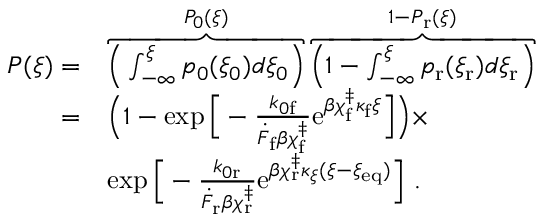Convert formula to latex. <formula><loc_0><loc_0><loc_500><loc_500>\begin{array} { r l } { P ( \xi ) = } & { \overbrace { \left ( \int _ { - \infty } ^ { \xi } p _ { 0 } ( \xi _ { 0 } ) d \xi _ { 0 } \right ) } ^ { P _ { 0 } ( \xi ) } \overbrace { \left ( 1 - \int _ { - \infty } ^ { \xi } p _ { r } ( \xi _ { r } ) d \xi _ { r } \right ) } ^ { 1 - P _ { r } ( \xi ) } } \\ { = } & { \left ( 1 - \exp \left [ - \frac { k _ { 0 f } } { \dot { F } _ { f } \beta \chi _ { f } ^ { \ddag } } e ^ { \beta \chi _ { f } ^ { \ddag } \kappa _ { f } \xi } \right ] \right ) \times } \\ & { \exp \left [ - \frac { k _ { 0 r } } { \dot { F } _ { r } \beta \chi _ { r } ^ { \ddag } } e ^ { \beta \chi _ { r } ^ { \ddag } \kappa _ { \xi } ( \xi - \xi _ { e q } ) } \right ] . } \end{array}</formula> 